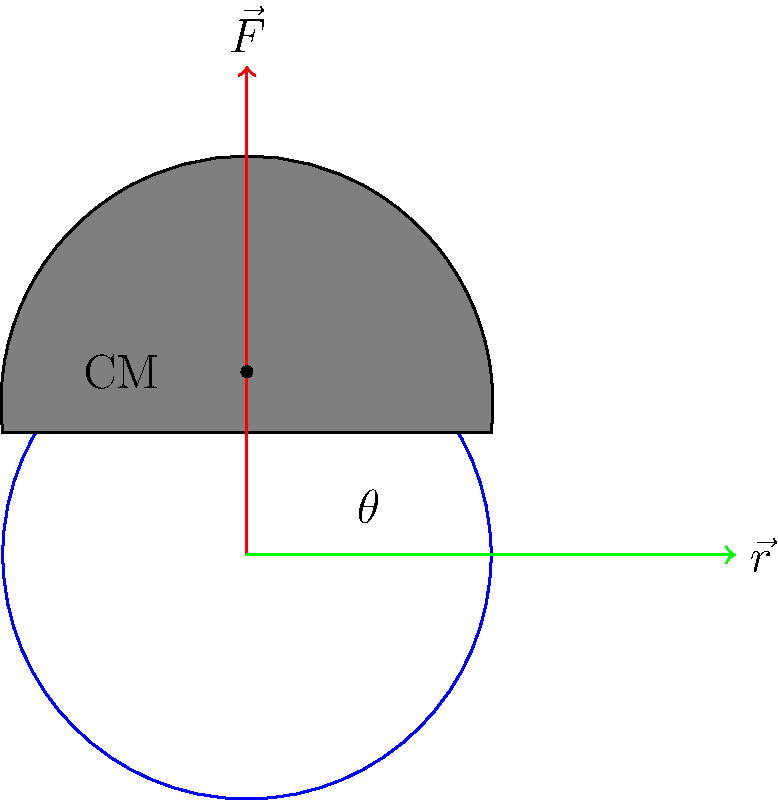As the circus manager, you're planning a new act where an elephant balances on a small rotating platform. The elephant's center of mass is 0.75 meters above the platform's surface, and the platform has a radius of 1 meter. If the elephant weighs 5000 kg and the angle between the applied force and the radius vector is 60°, what is the minimum torque required to keep the elephant balanced? To solve this problem, we'll follow these steps:

1. Recall the formula for torque: $\tau = r F \sin(\theta)$
   Where:
   $\tau$ = torque
   $r$ = radius (distance from axis of rotation to point of force application)
   $F$ = force
   $\theta$ = angle between force vector and radius vector

2. Calculate the force (F):
   $F = mg$, where $m$ is the mass and $g$ is the acceleration due to gravity (9.8 m/s²)
   $F = 5000 \text{ kg} \times 9.8 \text{ m/s²} = 49,000 \text{ N}$

3. Determine the radius (r):
   The radius is the distance from the center of the platform to the elephant's center of mass.
   $r = \sqrt{1^2 + 0.75^2} = \sqrt{1.5625} \approx 1.25 \text{ m}$

4. Use the given angle ($\theta = 60°$) and apply the torque formula:
   $\tau = 1.25 \text{ m} \times 49,000 \text{ N} \times \sin(60°)$
   $\tau = 1.25 \times 49,000 \times \frac{\sqrt{3}}{2}$
   $\tau \approx 53,033.01 \text{ N⋅m}$

5. Round to a reasonable number of significant figures:
   $\tau \approx 53,000 \text{ N⋅m}$

This is the minimum torque required to keep the elephant balanced on the rotating platform.
Answer: 53,000 N⋅m 